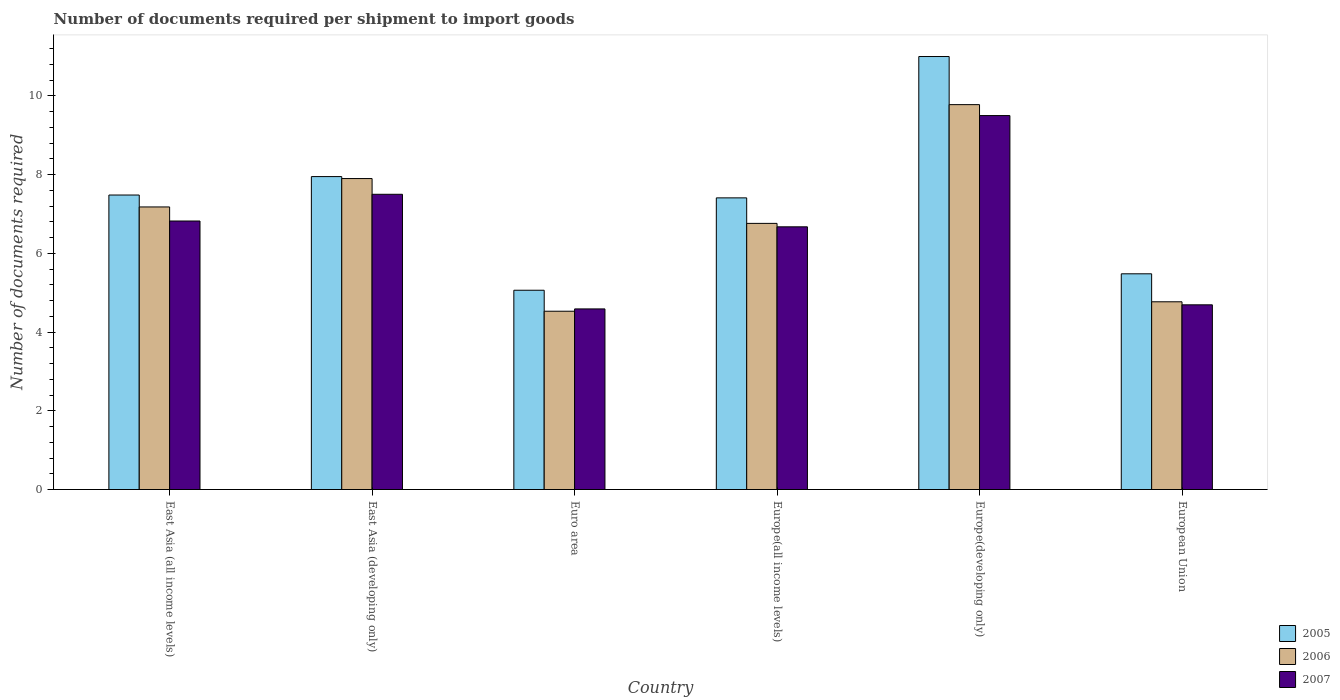How many different coloured bars are there?
Keep it short and to the point. 3. How many groups of bars are there?
Make the answer very short. 6. Are the number of bars per tick equal to the number of legend labels?
Provide a succinct answer. Yes. Are the number of bars on each tick of the X-axis equal?
Provide a succinct answer. Yes. How many bars are there on the 5th tick from the left?
Provide a succinct answer. 3. What is the label of the 5th group of bars from the left?
Give a very brief answer. Europe(developing only). In how many cases, is the number of bars for a given country not equal to the number of legend labels?
Offer a very short reply. 0. What is the number of documents required per shipment to import goods in 2006 in Europe(developing only)?
Your response must be concise. 9.78. Across all countries, what is the minimum number of documents required per shipment to import goods in 2007?
Keep it short and to the point. 4.59. In which country was the number of documents required per shipment to import goods in 2007 maximum?
Provide a short and direct response. Europe(developing only). What is the total number of documents required per shipment to import goods in 2007 in the graph?
Keep it short and to the point. 39.78. What is the difference between the number of documents required per shipment to import goods in 2007 in East Asia (developing only) and that in Europe(developing only)?
Give a very brief answer. -2. What is the difference between the number of documents required per shipment to import goods in 2007 in East Asia (all income levels) and the number of documents required per shipment to import goods in 2005 in East Asia (developing only)?
Your response must be concise. -1.13. What is the average number of documents required per shipment to import goods in 2006 per country?
Provide a succinct answer. 6.82. What is the difference between the number of documents required per shipment to import goods of/in 2007 and number of documents required per shipment to import goods of/in 2005 in Europe(all income levels)?
Ensure brevity in your answer.  -0.74. In how many countries, is the number of documents required per shipment to import goods in 2005 greater than 8.8?
Ensure brevity in your answer.  1. What is the ratio of the number of documents required per shipment to import goods in 2005 in East Asia (all income levels) to that in European Union?
Your response must be concise. 1.37. What is the difference between the highest and the second highest number of documents required per shipment to import goods in 2005?
Offer a terse response. 3.52. What is the difference between the highest and the lowest number of documents required per shipment to import goods in 2007?
Ensure brevity in your answer.  4.91. What does the 2nd bar from the right in East Asia (all income levels) represents?
Keep it short and to the point. 2006. Is it the case that in every country, the sum of the number of documents required per shipment to import goods in 2006 and number of documents required per shipment to import goods in 2007 is greater than the number of documents required per shipment to import goods in 2005?
Offer a very short reply. Yes. What is the difference between two consecutive major ticks on the Y-axis?
Provide a succinct answer. 2. Does the graph contain any zero values?
Your answer should be compact. No. Does the graph contain grids?
Offer a terse response. No. Where does the legend appear in the graph?
Make the answer very short. Bottom right. How many legend labels are there?
Ensure brevity in your answer.  3. What is the title of the graph?
Ensure brevity in your answer.  Number of documents required per shipment to import goods. What is the label or title of the Y-axis?
Give a very brief answer. Number of documents required. What is the Number of documents required in 2005 in East Asia (all income levels)?
Make the answer very short. 7.48. What is the Number of documents required in 2006 in East Asia (all income levels)?
Offer a very short reply. 7.18. What is the Number of documents required in 2007 in East Asia (all income levels)?
Your response must be concise. 6.82. What is the Number of documents required of 2005 in East Asia (developing only)?
Your answer should be very brief. 7.95. What is the Number of documents required of 2007 in East Asia (developing only)?
Offer a terse response. 7.5. What is the Number of documents required of 2005 in Euro area?
Your answer should be very brief. 5.06. What is the Number of documents required in 2006 in Euro area?
Offer a very short reply. 4.53. What is the Number of documents required of 2007 in Euro area?
Keep it short and to the point. 4.59. What is the Number of documents required of 2005 in Europe(all income levels)?
Keep it short and to the point. 7.41. What is the Number of documents required in 2006 in Europe(all income levels)?
Offer a very short reply. 6.76. What is the Number of documents required of 2007 in Europe(all income levels)?
Keep it short and to the point. 6.67. What is the Number of documents required in 2005 in Europe(developing only)?
Keep it short and to the point. 11. What is the Number of documents required in 2006 in Europe(developing only)?
Your answer should be compact. 9.78. What is the Number of documents required of 2007 in Europe(developing only)?
Give a very brief answer. 9.5. What is the Number of documents required in 2005 in European Union?
Your answer should be very brief. 5.48. What is the Number of documents required of 2006 in European Union?
Ensure brevity in your answer.  4.77. What is the Number of documents required of 2007 in European Union?
Provide a succinct answer. 4.69. Across all countries, what is the maximum Number of documents required in 2006?
Offer a terse response. 9.78. Across all countries, what is the maximum Number of documents required in 2007?
Offer a terse response. 9.5. Across all countries, what is the minimum Number of documents required of 2005?
Offer a very short reply. 5.06. Across all countries, what is the minimum Number of documents required of 2006?
Provide a short and direct response. 4.53. Across all countries, what is the minimum Number of documents required in 2007?
Provide a short and direct response. 4.59. What is the total Number of documents required in 2005 in the graph?
Give a very brief answer. 44.38. What is the total Number of documents required of 2006 in the graph?
Keep it short and to the point. 40.92. What is the total Number of documents required of 2007 in the graph?
Your answer should be compact. 39.78. What is the difference between the Number of documents required in 2005 in East Asia (all income levels) and that in East Asia (developing only)?
Your answer should be compact. -0.47. What is the difference between the Number of documents required in 2006 in East Asia (all income levels) and that in East Asia (developing only)?
Provide a short and direct response. -0.72. What is the difference between the Number of documents required of 2007 in East Asia (all income levels) and that in East Asia (developing only)?
Provide a succinct answer. -0.68. What is the difference between the Number of documents required of 2005 in East Asia (all income levels) and that in Euro area?
Your answer should be very brief. 2.42. What is the difference between the Number of documents required in 2006 in East Asia (all income levels) and that in Euro area?
Offer a terse response. 2.65. What is the difference between the Number of documents required in 2007 in East Asia (all income levels) and that in Euro area?
Offer a very short reply. 2.23. What is the difference between the Number of documents required of 2005 in East Asia (all income levels) and that in Europe(all income levels)?
Your answer should be compact. 0.07. What is the difference between the Number of documents required in 2006 in East Asia (all income levels) and that in Europe(all income levels)?
Ensure brevity in your answer.  0.42. What is the difference between the Number of documents required in 2007 in East Asia (all income levels) and that in Europe(all income levels)?
Ensure brevity in your answer.  0.15. What is the difference between the Number of documents required in 2005 in East Asia (all income levels) and that in Europe(developing only)?
Your answer should be very brief. -3.52. What is the difference between the Number of documents required in 2006 in East Asia (all income levels) and that in Europe(developing only)?
Offer a very short reply. -2.6. What is the difference between the Number of documents required of 2007 in East Asia (all income levels) and that in Europe(developing only)?
Offer a terse response. -2.68. What is the difference between the Number of documents required in 2005 in East Asia (all income levels) and that in European Union?
Ensure brevity in your answer.  2. What is the difference between the Number of documents required of 2006 in East Asia (all income levels) and that in European Union?
Your answer should be very brief. 2.41. What is the difference between the Number of documents required of 2007 in East Asia (all income levels) and that in European Union?
Ensure brevity in your answer.  2.13. What is the difference between the Number of documents required of 2005 in East Asia (developing only) and that in Euro area?
Your response must be concise. 2.89. What is the difference between the Number of documents required in 2006 in East Asia (developing only) and that in Euro area?
Provide a succinct answer. 3.37. What is the difference between the Number of documents required in 2007 in East Asia (developing only) and that in Euro area?
Provide a succinct answer. 2.91. What is the difference between the Number of documents required in 2005 in East Asia (developing only) and that in Europe(all income levels)?
Provide a succinct answer. 0.54. What is the difference between the Number of documents required of 2006 in East Asia (developing only) and that in Europe(all income levels)?
Provide a short and direct response. 1.14. What is the difference between the Number of documents required in 2007 in East Asia (developing only) and that in Europe(all income levels)?
Offer a very short reply. 0.83. What is the difference between the Number of documents required of 2005 in East Asia (developing only) and that in Europe(developing only)?
Ensure brevity in your answer.  -3.05. What is the difference between the Number of documents required in 2006 in East Asia (developing only) and that in Europe(developing only)?
Keep it short and to the point. -1.88. What is the difference between the Number of documents required in 2005 in East Asia (developing only) and that in European Union?
Ensure brevity in your answer.  2.47. What is the difference between the Number of documents required in 2006 in East Asia (developing only) and that in European Union?
Ensure brevity in your answer.  3.13. What is the difference between the Number of documents required in 2007 in East Asia (developing only) and that in European Union?
Offer a very short reply. 2.81. What is the difference between the Number of documents required in 2005 in Euro area and that in Europe(all income levels)?
Offer a terse response. -2.35. What is the difference between the Number of documents required of 2006 in Euro area and that in Europe(all income levels)?
Offer a terse response. -2.23. What is the difference between the Number of documents required of 2007 in Euro area and that in Europe(all income levels)?
Offer a terse response. -2.09. What is the difference between the Number of documents required of 2005 in Euro area and that in Europe(developing only)?
Your answer should be compact. -5.94. What is the difference between the Number of documents required in 2006 in Euro area and that in Europe(developing only)?
Your response must be concise. -5.25. What is the difference between the Number of documents required of 2007 in Euro area and that in Europe(developing only)?
Provide a short and direct response. -4.91. What is the difference between the Number of documents required of 2005 in Euro area and that in European Union?
Offer a terse response. -0.42. What is the difference between the Number of documents required in 2006 in Euro area and that in European Union?
Offer a terse response. -0.24. What is the difference between the Number of documents required of 2007 in Euro area and that in European Union?
Provide a short and direct response. -0.1. What is the difference between the Number of documents required in 2005 in Europe(all income levels) and that in Europe(developing only)?
Your answer should be very brief. -3.59. What is the difference between the Number of documents required in 2006 in Europe(all income levels) and that in Europe(developing only)?
Offer a very short reply. -3.02. What is the difference between the Number of documents required of 2007 in Europe(all income levels) and that in Europe(developing only)?
Your answer should be very brief. -2.83. What is the difference between the Number of documents required in 2005 in Europe(all income levels) and that in European Union?
Keep it short and to the point. 1.93. What is the difference between the Number of documents required in 2006 in Europe(all income levels) and that in European Union?
Offer a terse response. 1.99. What is the difference between the Number of documents required in 2007 in Europe(all income levels) and that in European Union?
Your answer should be very brief. 1.98. What is the difference between the Number of documents required of 2005 in Europe(developing only) and that in European Union?
Ensure brevity in your answer.  5.52. What is the difference between the Number of documents required of 2006 in Europe(developing only) and that in European Union?
Provide a short and direct response. 5.01. What is the difference between the Number of documents required of 2007 in Europe(developing only) and that in European Union?
Provide a short and direct response. 4.81. What is the difference between the Number of documents required of 2005 in East Asia (all income levels) and the Number of documents required of 2006 in East Asia (developing only)?
Keep it short and to the point. -0.42. What is the difference between the Number of documents required of 2005 in East Asia (all income levels) and the Number of documents required of 2007 in East Asia (developing only)?
Provide a succinct answer. -0.02. What is the difference between the Number of documents required in 2006 in East Asia (all income levels) and the Number of documents required in 2007 in East Asia (developing only)?
Make the answer very short. -0.32. What is the difference between the Number of documents required of 2005 in East Asia (all income levels) and the Number of documents required of 2006 in Euro area?
Provide a short and direct response. 2.95. What is the difference between the Number of documents required of 2005 in East Asia (all income levels) and the Number of documents required of 2007 in Euro area?
Ensure brevity in your answer.  2.89. What is the difference between the Number of documents required of 2006 in East Asia (all income levels) and the Number of documents required of 2007 in Euro area?
Ensure brevity in your answer.  2.59. What is the difference between the Number of documents required in 2005 in East Asia (all income levels) and the Number of documents required in 2006 in Europe(all income levels)?
Provide a succinct answer. 0.72. What is the difference between the Number of documents required in 2005 in East Asia (all income levels) and the Number of documents required in 2007 in Europe(all income levels)?
Offer a very short reply. 0.81. What is the difference between the Number of documents required of 2006 in East Asia (all income levels) and the Number of documents required of 2007 in Europe(all income levels)?
Provide a succinct answer. 0.5. What is the difference between the Number of documents required of 2005 in East Asia (all income levels) and the Number of documents required of 2006 in Europe(developing only)?
Provide a succinct answer. -2.3. What is the difference between the Number of documents required of 2005 in East Asia (all income levels) and the Number of documents required of 2007 in Europe(developing only)?
Offer a very short reply. -2.02. What is the difference between the Number of documents required of 2006 in East Asia (all income levels) and the Number of documents required of 2007 in Europe(developing only)?
Give a very brief answer. -2.32. What is the difference between the Number of documents required in 2005 in East Asia (all income levels) and the Number of documents required in 2006 in European Union?
Offer a very short reply. 2.71. What is the difference between the Number of documents required in 2005 in East Asia (all income levels) and the Number of documents required in 2007 in European Union?
Make the answer very short. 2.79. What is the difference between the Number of documents required of 2006 in East Asia (all income levels) and the Number of documents required of 2007 in European Union?
Give a very brief answer. 2.49. What is the difference between the Number of documents required in 2005 in East Asia (developing only) and the Number of documents required in 2006 in Euro area?
Ensure brevity in your answer.  3.42. What is the difference between the Number of documents required in 2005 in East Asia (developing only) and the Number of documents required in 2007 in Euro area?
Your answer should be compact. 3.36. What is the difference between the Number of documents required in 2006 in East Asia (developing only) and the Number of documents required in 2007 in Euro area?
Give a very brief answer. 3.31. What is the difference between the Number of documents required in 2005 in East Asia (developing only) and the Number of documents required in 2006 in Europe(all income levels)?
Ensure brevity in your answer.  1.19. What is the difference between the Number of documents required in 2005 in East Asia (developing only) and the Number of documents required in 2007 in Europe(all income levels)?
Your response must be concise. 1.28. What is the difference between the Number of documents required in 2006 in East Asia (developing only) and the Number of documents required in 2007 in Europe(all income levels)?
Offer a very short reply. 1.23. What is the difference between the Number of documents required in 2005 in East Asia (developing only) and the Number of documents required in 2006 in Europe(developing only)?
Provide a short and direct response. -1.83. What is the difference between the Number of documents required of 2005 in East Asia (developing only) and the Number of documents required of 2007 in Europe(developing only)?
Give a very brief answer. -1.55. What is the difference between the Number of documents required of 2005 in East Asia (developing only) and the Number of documents required of 2006 in European Union?
Ensure brevity in your answer.  3.18. What is the difference between the Number of documents required of 2005 in East Asia (developing only) and the Number of documents required of 2007 in European Union?
Your answer should be very brief. 3.26. What is the difference between the Number of documents required of 2006 in East Asia (developing only) and the Number of documents required of 2007 in European Union?
Your response must be concise. 3.21. What is the difference between the Number of documents required in 2005 in Euro area and the Number of documents required in 2006 in Europe(all income levels)?
Keep it short and to the point. -1.7. What is the difference between the Number of documents required in 2005 in Euro area and the Number of documents required in 2007 in Europe(all income levels)?
Make the answer very short. -1.61. What is the difference between the Number of documents required of 2006 in Euro area and the Number of documents required of 2007 in Europe(all income levels)?
Ensure brevity in your answer.  -2.14. What is the difference between the Number of documents required of 2005 in Euro area and the Number of documents required of 2006 in Europe(developing only)?
Provide a short and direct response. -4.72. What is the difference between the Number of documents required of 2005 in Euro area and the Number of documents required of 2007 in Europe(developing only)?
Your answer should be very brief. -4.44. What is the difference between the Number of documents required of 2006 in Euro area and the Number of documents required of 2007 in Europe(developing only)?
Make the answer very short. -4.97. What is the difference between the Number of documents required in 2005 in Euro area and the Number of documents required in 2006 in European Union?
Offer a terse response. 0.29. What is the difference between the Number of documents required in 2005 in Euro area and the Number of documents required in 2007 in European Union?
Offer a terse response. 0.37. What is the difference between the Number of documents required of 2006 in Euro area and the Number of documents required of 2007 in European Union?
Offer a terse response. -0.16. What is the difference between the Number of documents required in 2005 in Europe(all income levels) and the Number of documents required in 2006 in Europe(developing only)?
Provide a succinct answer. -2.37. What is the difference between the Number of documents required in 2005 in Europe(all income levels) and the Number of documents required in 2007 in Europe(developing only)?
Provide a short and direct response. -2.09. What is the difference between the Number of documents required of 2006 in Europe(all income levels) and the Number of documents required of 2007 in Europe(developing only)?
Make the answer very short. -2.74. What is the difference between the Number of documents required of 2005 in Europe(all income levels) and the Number of documents required of 2006 in European Union?
Provide a succinct answer. 2.64. What is the difference between the Number of documents required in 2005 in Europe(all income levels) and the Number of documents required in 2007 in European Union?
Your answer should be compact. 2.72. What is the difference between the Number of documents required of 2006 in Europe(all income levels) and the Number of documents required of 2007 in European Union?
Keep it short and to the point. 2.07. What is the difference between the Number of documents required in 2005 in Europe(developing only) and the Number of documents required in 2006 in European Union?
Provide a short and direct response. 6.23. What is the difference between the Number of documents required in 2005 in Europe(developing only) and the Number of documents required in 2007 in European Union?
Keep it short and to the point. 6.31. What is the difference between the Number of documents required of 2006 in Europe(developing only) and the Number of documents required of 2007 in European Union?
Your answer should be compact. 5.09. What is the average Number of documents required of 2005 per country?
Keep it short and to the point. 7.4. What is the average Number of documents required in 2006 per country?
Offer a very short reply. 6.82. What is the average Number of documents required in 2007 per country?
Offer a terse response. 6.63. What is the difference between the Number of documents required of 2005 and Number of documents required of 2006 in East Asia (all income levels)?
Make the answer very short. 0.3. What is the difference between the Number of documents required in 2005 and Number of documents required in 2007 in East Asia (all income levels)?
Keep it short and to the point. 0.66. What is the difference between the Number of documents required of 2006 and Number of documents required of 2007 in East Asia (all income levels)?
Ensure brevity in your answer.  0.36. What is the difference between the Number of documents required of 2005 and Number of documents required of 2007 in East Asia (developing only)?
Give a very brief answer. 0.45. What is the difference between the Number of documents required in 2006 and Number of documents required in 2007 in East Asia (developing only)?
Ensure brevity in your answer.  0.4. What is the difference between the Number of documents required in 2005 and Number of documents required in 2006 in Euro area?
Offer a very short reply. 0.53. What is the difference between the Number of documents required in 2005 and Number of documents required in 2007 in Euro area?
Ensure brevity in your answer.  0.47. What is the difference between the Number of documents required in 2006 and Number of documents required in 2007 in Euro area?
Your response must be concise. -0.06. What is the difference between the Number of documents required in 2005 and Number of documents required in 2006 in Europe(all income levels)?
Offer a very short reply. 0.65. What is the difference between the Number of documents required in 2005 and Number of documents required in 2007 in Europe(all income levels)?
Give a very brief answer. 0.74. What is the difference between the Number of documents required in 2006 and Number of documents required in 2007 in Europe(all income levels)?
Offer a very short reply. 0.09. What is the difference between the Number of documents required of 2005 and Number of documents required of 2006 in Europe(developing only)?
Provide a short and direct response. 1.22. What is the difference between the Number of documents required in 2006 and Number of documents required in 2007 in Europe(developing only)?
Give a very brief answer. 0.28. What is the difference between the Number of documents required in 2005 and Number of documents required in 2006 in European Union?
Your response must be concise. 0.71. What is the difference between the Number of documents required in 2005 and Number of documents required in 2007 in European Union?
Offer a terse response. 0.79. What is the difference between the Number of documents required of 2006 and Number of documents required of 2007 in European Union?
Provide a succinct answer. 0.08. What is the ratio of the Number of documents required of 2005 in East Asia (all income levels) to that in East Asia (developing only)?
Offer a terse response. 0.94. What is the ratio of the Number of documents required of 2006 in East Asia (all income levels) to that in East Asia (developing only)?
Offer a terse response. 0.91. What is the ratio of the Number of documents required in 2007 in East Asia (all income levels) to that in East Asia (developing only)?
Provide a short and direct response. 0.91. What is the ratio of the Number of documents required of 2005 in East Asia (all income levels) to that in Euro area?
Keep it short and to the point. 1.48. What is the ratio of the Number of documents required in 2006 in East Asia (all income levels) to that in Euro area?
Make the answer very short. 1.58. What is the ratio of the Number of documents required of 2007 in East Asia (all income levels) to that in Euro area?
Keep it short and to the point. 1.49. What is the ratio of the Number of documents required in 2005 in East Asia (all income levels) to that in Europe(all income levels)?
Offer a terse response. 1.01. What is the ratio of the Number of documents required in 2006 in East Asia (all income levels) to that in Europe(all income levels)?
Provide a short and direct response. 1.06. What is the ratio of the Number of documents required of 2007 in East Asia (all income levels) to that in Europe(all income levels)?
Your response must be concise. 1.02. What is the ratio of the Number of documents required in 2005 in East Asia (all income levels) to that in Europe(developing only)?
Make the answer very short. 0.68. What is the ratio of the Number of documents required in 2006 in East Asia (all income levels) to that in Europe(developing only)?
Your answer should be very brief. 0.73. What is the ratio of the Number of documents required of 2007 in East Asia (all income levels) to that in Europe(developing only)?
Your answer should be very brief. 0.72. What is the ratio of the Number of documents required of 2005 in East Asia (all income levels) to that in European Union?
Give a very brief answer. 1.37. What is the ratio of the Number of documents required of 2006 in East Asia (all income levels) to that in European Union?
Keep it short and to the point. 1.51. What is the ratio of the Number of documents required of 2007 in East Asia (all income levels) to that in European Union?
Offer a very short reply. 1.45. What is the ratio of the Number of documents required of 2005 in East Asia (developing only) to that in Euro area?
Keep it short and to the point. 1.57. What is the ratio of the Number of documents required of 2006 in East Asia (developing only) to that in Euro area?
Give a very brief answer. 1.74. What is the ratio of the Number of documents required in 2007 in East Asia (developing only) to that in Euro area?
Provide a succinct answer. 1.63. What is the ratio of the Number of documents required in 2005 in East Asia (developing only) to that in Europe(all income levels)?
Your answer should be very brief. 1.07. What is the ratio of the Number of documents required in 2006 in East Asia (developing only) to that in Europe(all income levels)?
Provide a succinct answer. 1.17. What is the ratio of the Number of documents required in 2007 in East Asia (developing only) to that in Europe(all income levels)?
Make the answer very short. 1.12. What is the ratio of the Number of documents required of 2005 in East Asia (developing only) to that in Europe(developing only)?
Offer a very short reply. 0.72. What is the ratio of the Number of documents required of 2006 in East Asia (developing only) to that in Europe(developing only)?
Your answer should be very brief. 0.81. What is the ratio of the Number of documents required in 2007 in East Asia (developing only) to that in Europe(developing only)?
Provide a short and direct response. 0.79. What is the ratio of the Number of documents required of 2005 in East Asia (developing only) to that in European Union?
Ensure brevity in your answer.  1.45. What is the ratio of the Number of documents required of 2006 in East Asia (developing only) to that in European Union?
Give a very brief answer. 1.66. What is the ratio of the Number of documents required of 2007 in East Asia (developing only) to that in European Union?
Your response must be concise. 1.6. What is the ratio of the Number of documents required in 2005 in Euro area to that in Europe(all income levels)?
Make the answer very short. 0.68. What is the ratio of the Number of documents required of 2006 in Euro area to that in Europe(all income levels)?
Your answer should be compact. 0.67. What is the ratio of the Number of documents required of 2007 in Euro area to that in Europe(all income levels)?
Offer a very short reply. 0.69. What is the ratio of the Number of documents required in 2005 in Euro area to that in Europe(developing only)?
Ensure brevity in your answer.  0.46. What is the ratio of the Number of documents required in 2006 in Euro area to that in Europe(developing only)?
Offer a terse response. 0.46. What is the ratio of the Number of documents required of 2007 in Euro area to that in Europe(developing only)?
Keep it short and to the point. 0.48. What is the ratio of the Number of documents required in 2005 in Euro area to that in European Union?
Your answer should be compact. 0.92. What is the ratio of the Number of documents required of 2006 in Euro area to that in European Union?
Give a very brief answer. 0.95. What is the ratio of the Number of documents required of 2007 in Euro area to that in European Union?
Your answer should be compact. 0.98. What is the ratio of the Number of documents required of 2005 in Europe(all income levels) to that in Europe(developing only)?
Your answer should be compact. 0.67. What is the ratio of the Number of documents required in 2006 in Europe(all income levels) to that in Europe(developing only)?
Ensure brevity in your answer.  0.69. What is the ratio of the Number of documents required in 2007 in Europe(all income levels) to that in Europe(developing only)?
Provide a succinct answer. 0.7. What is the ratio of the Number of documents required of 2005 in Europe(all income levels) to that in European Union?
Offer a very short reply. 1.35. What is the ratio of the Number of documents required in 2006 in Europe(all income levels) to that in European Union?
Provide a short and direct response. 1.42. What is the ratio of the Number of documents required in 2007 in Europe(all income levels) to that in European Union?
Offer a terse response. 1.42. What is the ratio of the Number of documents required of 2005 in Europe(developing only) to that in European Union?
Ensure brevity in your answer.  2.01. What is the ratio of the Number of documents required in 2006 in Europe(developing only) to that in European Union?
Provide a succinct answer. 2.05. What is the ratio of the Number of documents required in 2007 in Europe(developing only) to that in European Union?
Offer a very short reply. 2.02. What is the difference between the highest and the second highest Number of documents required of 2005?
Keep it short and to the point. 3.05. What is the difference between the highest and the second highest Number of documents required of 2006?
Keep it short and to the point. 1.88. What is the difference between the highest and the second highest Number of documents required of 2007?
Keep it short and to the point. 2. What is the difference between the highest and the lowest Number of documents required in 2005?
Your answer should be very brief. 5.94. What is the difference between the highest and the lowest Number of documents required in 2006?
Make the answer very short. 5.25. What is the difference between the highest and the lowest Number of documents required in 2007?
Make the answer very short. 4.91. 